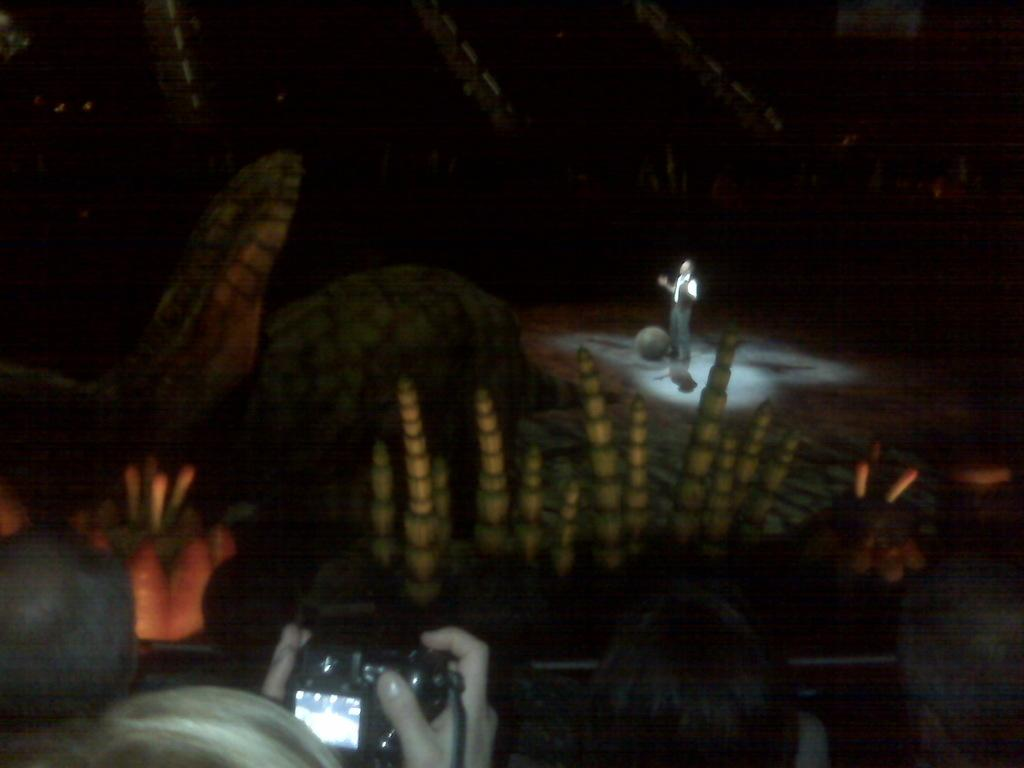What is the main subject of the image? There is a man standing in the image. Can you describe the man's surroundings? The man is standing in a spotlight. What are the other people in the image doing? There are people sitting in the image. Who is capturing the scene? There is a person holding a camera in the image. How many boys are visible in the image? There is no mention of boys in the image, so we cannot determine their presence or number. Is there a door visible in the image? There is no mention of a door in the image, so we cannot determine its presence. 